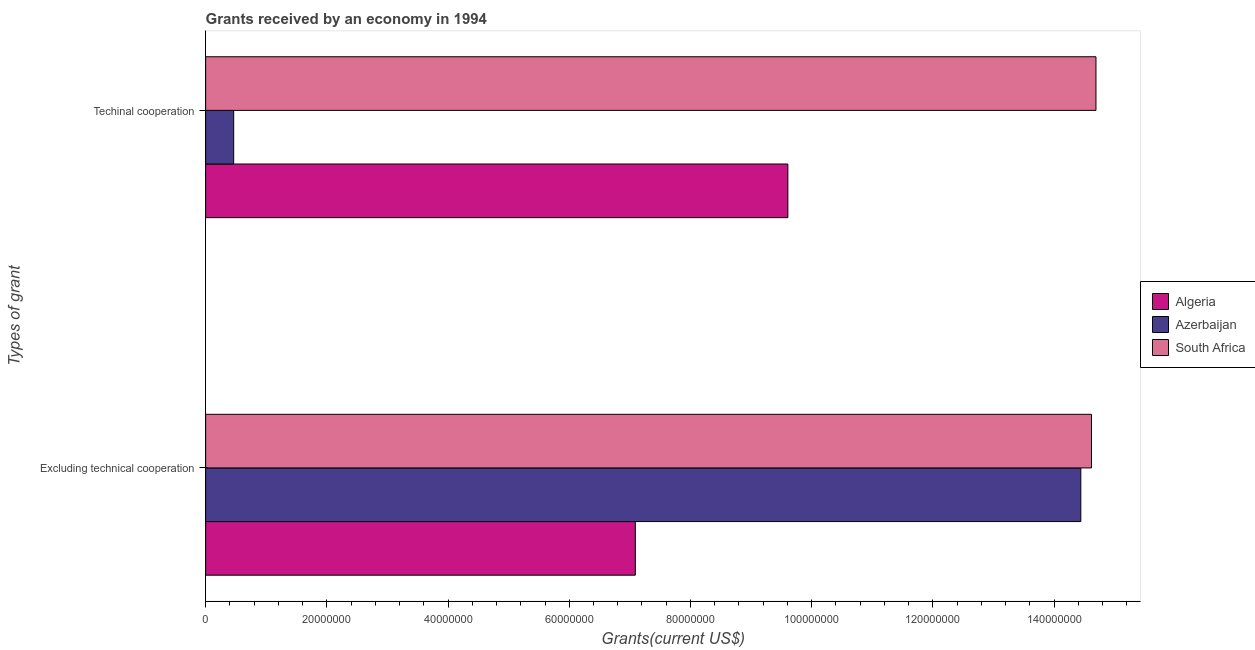How many different coloured bars are there?
Your response must be concise. 3. Are the number of bars per tick equal to the number of legend labels?
Give a very brief answer. Yes. Are the number of bars on each tick of the Y-axis equal?
Make the answer very short. Yes. How many bars are there on the 1st tick from the top?
Provide a succinct answer. 3. How many bars are there on the 2nd tick from the bottom?
Your answer should be compact. 3. What is the label of the 2nd group of bars from the top?
Your answer should be very brief. Excluding technical cooperation. What is the amount of grants received(including technical cooperation) in Azerbaijan?
Ensure brevity in your answer.  4.63e+06. Across all countries, what is the maximum amount of grants received(excluding technical cooperation)?
Make the answer very short. 1.46e+08. Across all countries, what is the minimum amount of grants received(including technical cooperation)?
Offer a terse response. 4.63e+06. In which country was the amount of grants received(excluding technical cooperation) maximum?
Your response must be concise. South Africa. In which country was the amount of grants received(excluding technical cooperation) minimum?
Offer a very short reply. Algeria. What is the total amount of grants received(excluding technical cooperation) in the graph?
Make the answer very short. 3.61e+08. What is the difference between the amount of grants received(including technical cooperation) in Azerbaijan and that in Algeria?
Provide a succinct answer. -9.14e+07. What is the difference between the amount of grants received(excluding technical cooperation) in Algeria and the amount of grants received(including technical cooperation) in Azerbaijan?
Offer a terse response. 6.63e+07. What is the average amount of grants received(including technical cooperation) per country?
Keep it short and to the point. 8.25e+07. What is the difference between the amount of grants received(excluding technical cooperation) and amount of grants received(including technical cooperation) in Azerbaijan?
Ensure brevity in your answer.  1.40e+08. In how many countries, is the amount of grants received(including technical cooperation) greater than 132000000 US$?
Offer a terse response. 1. What is the ratio of the amount of grants received(including technical cooperation) in Algeria to that in South Africa?
Ensure brevity in your answer.  0.65. Is the amount of grants received(excluding technical cooperation) in South Africa less than that in Algeria?
Give a very brief answer. No. In how many countries, is the amount of grants received(excluding technical cooperation) greater than the average amount of grants received(excluding technical cooperation) taken over all countries?
Keep it short and to the point. 2. What does the 1st bar from the top in Excluding technical cooperation represents?
Ensure brevity in your answer.  South Africa. What does the 3rd bar from the bottom in Techinal cooperation represents?
Make the answer very short. South Africa. How many bars are there?
Your response must be concise. 6. Are all the bars in the graph horizontal?
Make the answer very short. Yes. Are the values on the major ticks of X-axis written in scientific E-notation?
Give a very brief answer. No. Does the graph contain grids?
Keep it short and to the point. No. Where does the legend appear in the graph?
Ensure brevity in your answer.  Center right. How many legend labels are there?
Ensure brevity in your answer.  3. How are the legend labels stacked?
Offer a very short reply. Vertical. What is the title of the graph?
Your answer should be very brief. Grants received by an economy in 1994. What is the label or title of the X-axis?
Give a very brief answer. Grants(current US$). What is the label or title of the Y-axis?
Your answer should be very brief. Types of grant. What is the Grants(current US$) in Algeria in Excluding technical cooperation?
Provide a succinct answer. 7.09e+07. What is the Grants(current US$) in Azerbaijan in Excluding technical cooperation?
Offer a very short reply. 1.44e+08. What is the Grants(current US$) of South Africa in Excluding technical cooperation?
Make the answer very short. 1.46e+08. What is the Grants(current US$) of Algeria in Techinal cooperation?
Keep it short and to the point. 9.61e+07. What is the Grants(current US$) in Azerbaijan in Techinal cooperation?
Offer a very short reply. 4.63e+06. What is the Grants(current US$) in South Africa in Techinal cooperation?
Your response must be concise. 1.47e+08. Across all Types of grant, what is the maximum Grants(current US$) of Algeria?
Offer a very short reply. 9.61e+07. Across all Types of grant, what is the maximum Grants(current US$) in Azerbaijan?
Keep it short and to the point. 1.44e+08. Across all Types of grant, what is the maximum Grants(current US$) of South Africa?
Offer a very short reply. 1.47e+08. Across all Types of grant, what is the minimum Grants(current US$) of Algeria?
Your response must be concise. 7.09e+07. Across all Types of grant, what is the minimum Grants(current US$) in Azerbaijan?
Provide a short and direct response. 4.63e+06. Across all Types of grant, what is the minimum Grants(current US$) in South Africa?
Give a very brief answer. 1.46e+08. What is the total Grants(current US$) of Algeria in the graph?
Provide a succinct answer. 1.67e+08. What is the total Grants(current US$) in Azerbaijan in the graph?
Make the answer very short. 1.49e+08. What is the total Grants(current US$) of South Africa in the graph?
Your response must be concise. 2.93e+08. What is the difference between the Grants(current US$) of Algeria in Excluding technical cooperation and that in Techinal cooperation?
Ensure brevity in your answer.  -2.52e+07. What is the difference between the Grants(current US$) in Azerbaijan in Excluding technical cooperation and that in Techinal cooperation?
Offer a very short reply. 1.40e+08. What is the difference between the Grants(current US$) of South Africa in Excluding technical cooperation and that in Techinal cooperation?
Make the answer very short. -7.40e+05. What is the difference between the Grants(current US$) in Algeria in Excluding technical cooperation and the Grants(current US$) in Azerbaijan in Techinal cooperation?
Keep it short and to the point. 6.63e+07. What is the difference between the Grants(current US$) of Algeria in Excluding technical cooperation and the Grants(current US$) of South Africa in Techinal cooperation?
Offer a very short reply. -7.60e+07. What is the difference between the Grants(current US$) in Azerbaijan in Excluding technical cooperation and the Grants(current US$) in South Africa in Techinal cooperation?
Provide a short and direct response. -2.50e+06. What is the average Grants(current US$) of Algeria per Types of grant?
Ensure brevity in your answer.  8.35e+07. What is the average Grants(current US$) of Azerbaijan per Types of grant?
Ensure brevity in your answer.  7.45e+07. What is the average Grants(current US$) of South Africa per Types of grant?
Your response must be concise. 1.47e+08. What is the difference between the Grants(current US$) in Algeria and Grants(current US$) in Azerbaijan in Excluding technical cooperation?
Ensure brevity in your answer.  -7.35e+07. What is the difference between the Grants(current US$) in Algeria and Grants(current US$) in South Africa in Excluding technical cooperation?
Your answer should be very brief. -7.53e+07. What is the difference between the Grants(current US$) in Azerbaijan and Grants(current US$) in South Africa in Excluding technical cooperation?
Provide a succinct answer. -1.76e+06. What is the difference between the Grants(current US$) in Algeria and Grants(current US$) in Azerbaijan in Techinal cooperation?
Make the answer very short. 9.14e+07. What is the difference between the Grants(current US$) of Algeria and Grants(current US$) of South Africa in Techinal cooperation?
Your response must be concise. -5.08e+07. What is the difference between the Grants(current US$) of Azerbaijan and Grants(current US$) of South Africa in Techinal cooperation?
Provide a succinct answer. -1.42e+08. What is the ratio of the Grants(current US$) of Algeria in Excluding technical cooperation to that in Techinal cooperation?
Keep it short and to the point. 0.74. What is the ratio of the Grants(current US$) in Azerbaijan in Excluding technical cooperation to that in Techinal cooperation?
Offer a very short reply. 31.19. What is the difference between the highest and the second highest Grants(current US$) in Algeria?
Give a very brief answer. 2.52e+07. What is the difference between the highest and the second highest Grants(current US$) of Azerbaijan?
Provide a succinct answer. 1.40e+08. What is the difference between the highest and the second highest Grants(current US$) of South Africa?
Ensure brevity in your answer.  7.40e+05. What is the difference between the highest and the lowest Grants(current US$) of Algeria?
Make the answer very short. 2.52e+07. What is the difference between the highest and the lowest Grants(current US$) of Azerbaijan?
Offer a terse response. 1.40e+08. What is the difference between the highest and the lowest Grants(current US$) of South Africa?
Offer a very short reply. 7.40e+05. 